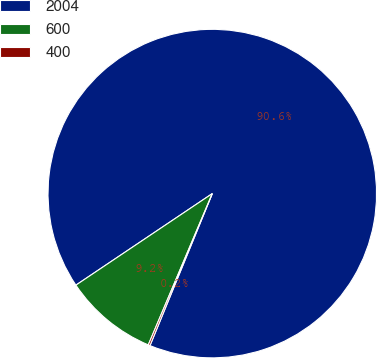Convert chart to OTSL. <chart><loc_0><loc_0><loc_500><loc_500><pie_chart><fcel>2004<fcel>600<fcel>400<nl><fcel>90.6%<fcel>9.22%<fcel>0.18%<nl></chart> 